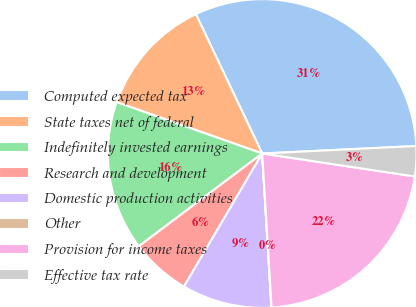<chart> <loc_0><loc_0><loc_500><loc_500><pie_chart><fcel>Computed expected tax<fcel>State taxes net of federal<fcel>Indefinitely invested earnings<fcel>Research and development<fcel>Domestic production activities<fcel>Other<fcel>Provision for income taxes<fcel>Effective tax rate<nl><fcel>31.3%<fcel>12.53%<fcel>15.66%<fcel>6.28%<fcel>9.41%<fcel>0.02%<fcel>21.65%<fcel>3.15%<nl></chart> 